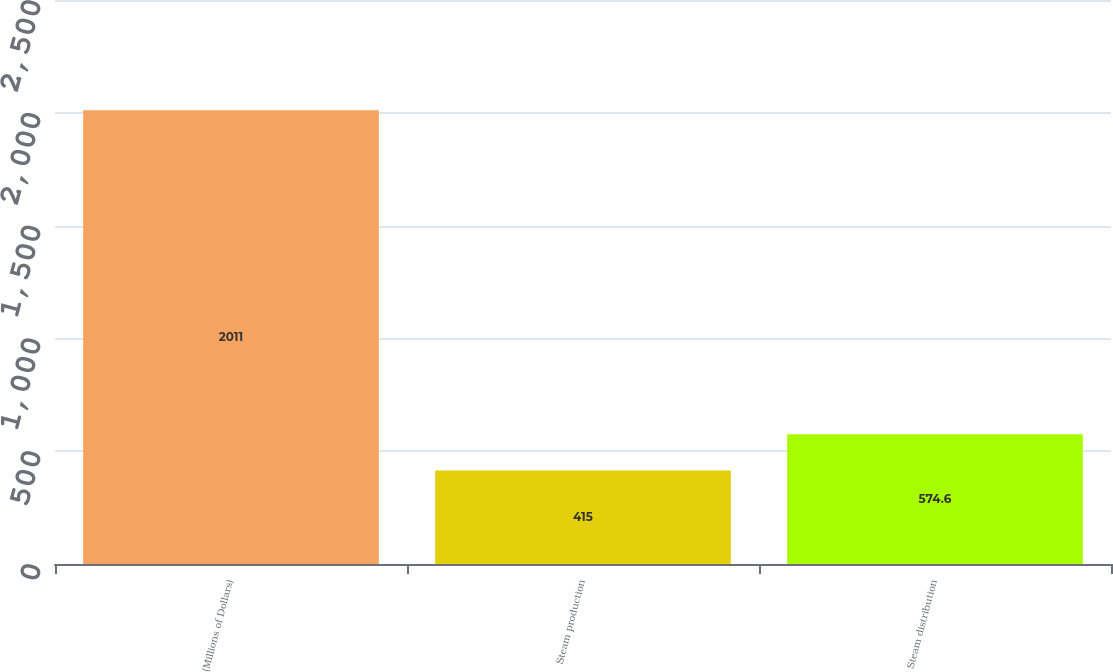Convert chart to OTSL. <chart><loc_0><loc_0><loc_500><loc_500><bar_chart><fcel>(Millions of Dollars)<fcel>Steam production<fcel>Steam distribution<nl><fcel>2011<fcel>415<fcel>574.6<nl></chart> 